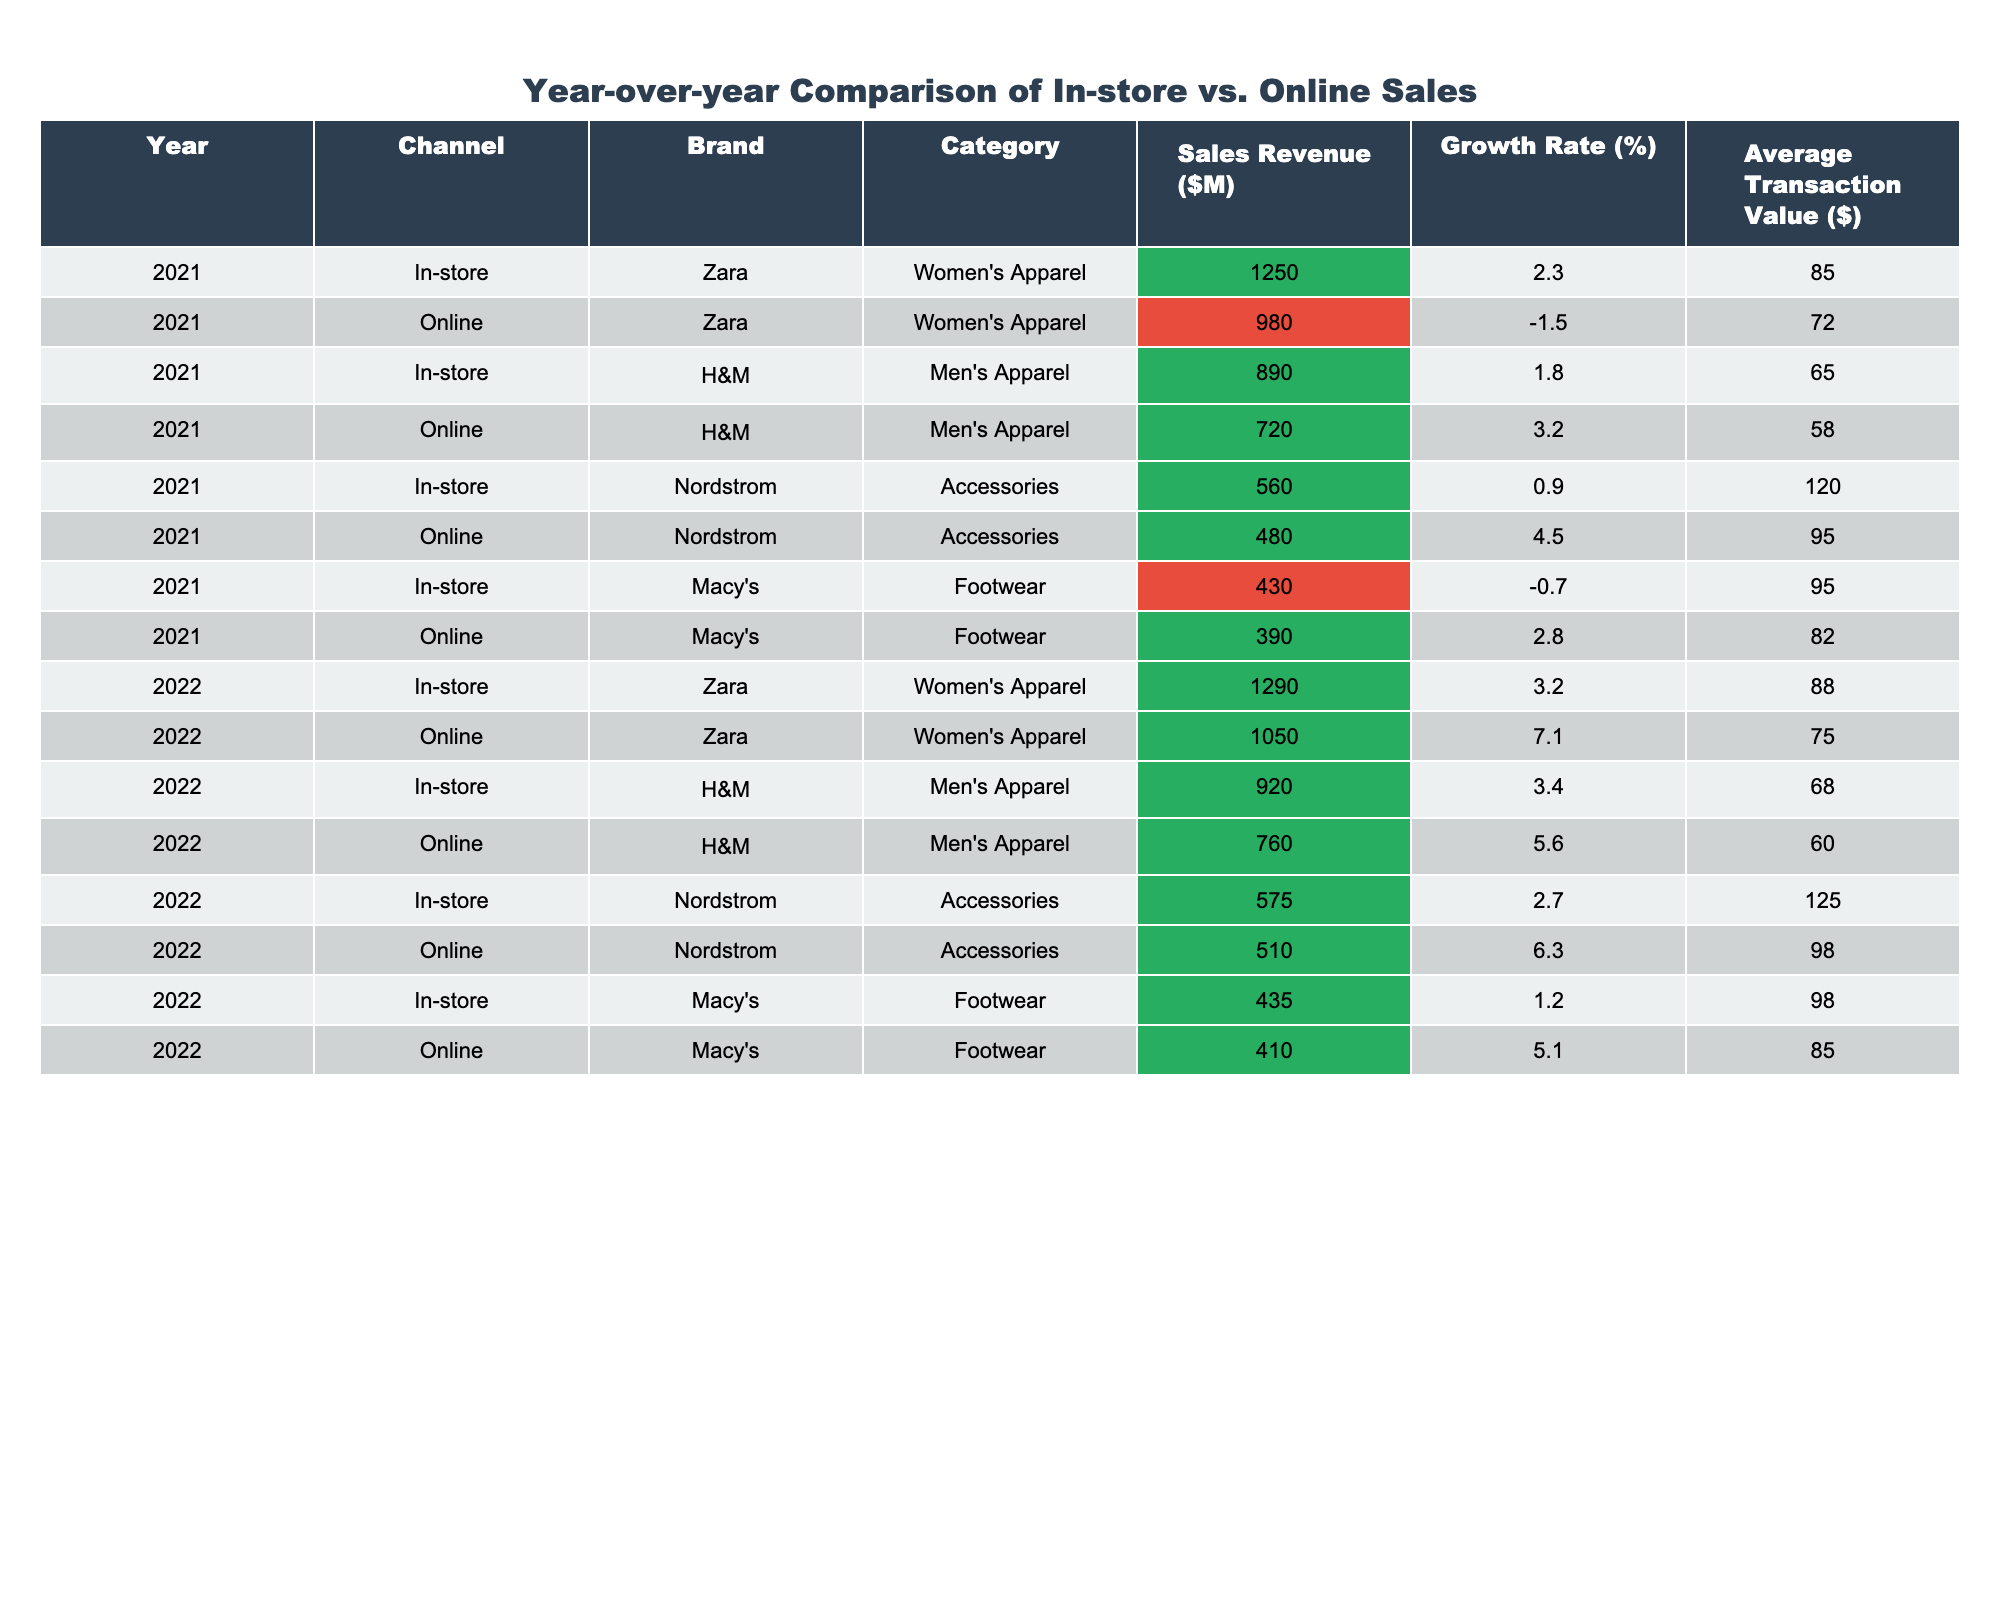What was the sales revenue of H&M's online men's apparel in 2022? The table clearly states the sales revenue for H&M's online men's apparel in 2022, which is listed as $760 million.
Answer: 760 What was the growth rate of Zara's in-store women's apparel from 2021 to 2022? The growth rate for Zara's in-store women's apparel in 2021 is 2.3%, while in 2022 it is 3.2%. The difference shows an increase of 0.9%.
Answer: 0.9% Which channel had higher sales revenue for Nordstrom's accessories in both years? By comparing the sales revenue for Nordstrom's accessories, in 2021 it was $560 million (in-store) vs. $480 million (online) and in 2022 it was $575 million (in-store) vs. $510 million (online). In both years, in-store sales were higher.
Answer: In-store What was the average transaction value of Macy's online footwear in 2022? The average transaction value for Macy's online footwear in 2022 is listed as $85.
Answer: 85 What is the difference in sales revenue for Zara's online women's apparel between 2021 and 2022? The sales revenue for Zara's online women's apparel is $980 million in 2021 and $1,050 million in 2022. The difference is calculated as $1,050 - $980 = $70 million.
Answer: 70 Did H&M's online men's apparel have a higher growth rate in 2021 or 2022? H&M's online men's apparel growth rate was 3.2% in 2021 and 5.6% in 2022. Therefore, the growth rate was higher in 2022.
Answer: Yes What is the total sales revenue for Macy's footwear across both years? The total sales revenue for Macy's footwear is the sum of both years': $430 million (2021) + $435 million (2022) = $865 million.
Answer: 865 Which brand had the highest average transaction value in 2021 for in-store purchases? In 2021, Nordstrom had the highest average transaction value for in-store purchases at $120.
Answer: Nordstrom If you combine the online sales for Zara and H&M in 2022, what is the total sales revenue? For Zara online in 2022, the sales revenue is $1,050 million and for H&M it's $760 million. The total is $1,050 + $760 = $1,810 million.
Answer: 1810 What was the year-over-year growth rate for online sales of Nordstrom's accessories? The growth rate for Nordstrom's online accessories went from 4.5% in 2021 to 6.3% in 2022, resulting in an increase of 1.8%.
Answer: 1.8 